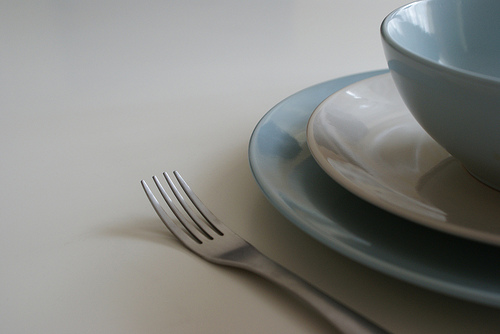<image>
Can you confirm if the bowl is on the table? Yes. Looking at the image, I can see the bowl is positioned on top of the table, with the table providing support. 